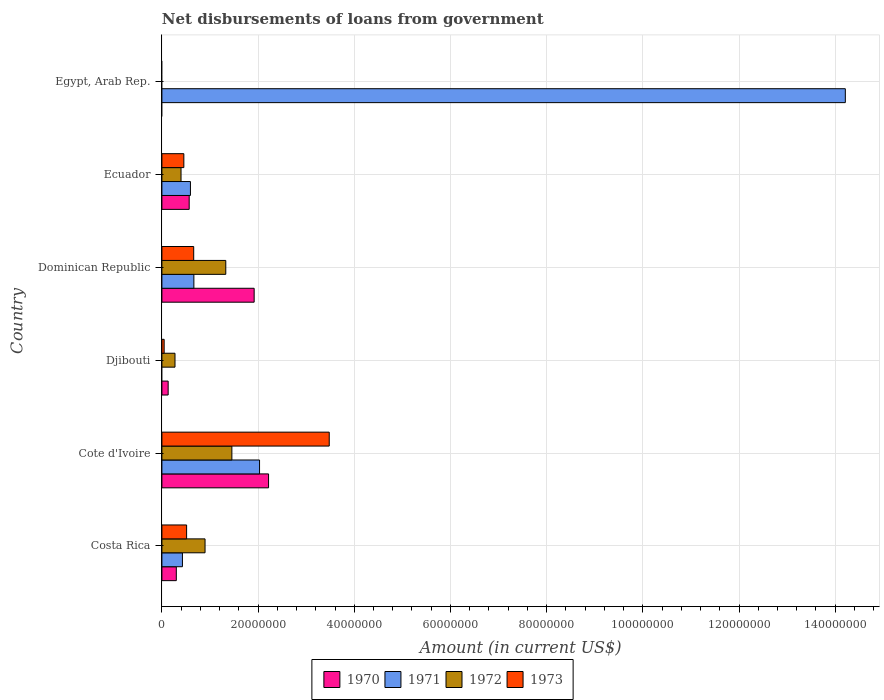Are the number of bars per tick equal to the number of legend labels?
Give a very brief answer. No. What is the label of the 6th group of bars from the top?
Ensure brevity in your answer.  Costa Rica. In how many cases, is the number of bars for a given country not equal to the number of legend labels?
Keep it short and to the point. 2. What is the amount of loan disbursed from government in 1971 in Egypt, Arab Rep.?
Offer a very short reply. 1.42e+08. Across all countries, what is the maximum amount of loan disbursed from government in 1973?
Your answer should be very brief. 3.48e+07. Across all countries, what is the minimum amount of loan disbursed from government in 1972?
Your answer should be compact. 0. In which country was the amount of loan disbursed from government in 1973 maximum?
Offer a very short reply. Cote d'Ivoire. What is the total amount of loan disbursed from government in 1970 in the graph?
Offer a terse response. 5.13e+07. What is the difference between the amount of loan disbursed from government in 1973 in Djibouti and that in Ecuador?
Keep it short and to the point. -4.10e+06. What is the difference between the amount of loan disbursed from government in 1973 in Egypt, Arab Rep. and the amount of loan disbursed from government in 1970 in Ecuador?
Provide a succinct answer. -5.67e+06. What is the average amount of loan disbursed from government in 1973 per country?
Provide a short and direct response. 8.60e+06. What is the difference between the amount of loan disbursed from government in 1972 and amount of loan disbursed from government in 1973 in Ecuador?
Your answer should be compact. -5.84e+05. What is the ratio of the amount of loan disbursed from government in 1973 in Dominican Republic to that in Ecuador?
Provide a short and direct response. 1.45. Is the amount of loan disbursed from government in 1972 in Cote d'Ivoire less than that in Dominican Republic?
Your answer should be very brief. No. What is the difference between the highest and the second highest amount of loan disbursed from government in 1973?
Provide a short and direct response. 2.82e+07. What is the difference between the highest and the lowest amount of loan disbursed from government in 1973?
Your answer should be compact. 3.48e+07. Is the sum of the amount of loan disbursed from government in 1972 in Djibouti and Dominican Republic greater than the maximum amount of loan disbursed from government in 1973 across all countries?
Provide a succinct answer. No. Is it the case that in every country, the sum of the amount of loan disbursed from government in 1972 and amount of loan disbursed from government in 1970 is greater than the amount of loan disbursed from government in 1971?
Give a very brief answer. No. What is the difference between two consecutive major ticks on the X-axis?
Ensure brevity in your answer.  2.00e+07. Are the values on the major ticks of X-axis written in scientific E-notation?
Your answer should be very brief. No. Does the graph contain any zero values?
Give a very brief answer. Yes. What is the title of the graph?
Your answer should be compact. Net disbursements of loans from government. Does "1982" appear as one of the legend labels in the graph?
Provide a succinct answer. No. What is the Amount (in current US$) in 1970 in Costa Rica?
Your answer should be very brief. 3.00e+06. What is the Amount (in current US$) of 1971 in Costa Rica?
Ensure brevity in your answer.  4.27e+06. What is the Amount (in current US$) in 1972 in Costa Rica?
Make the answer very short. 8.97e+06. What is the Amount (in current US$) of 1973 in Costa Rica?
Offer a very short reply. 5.14e+06. What is the Amount (in current US$) of 1970 in Cote d'Ivoire?
Keep it short and to the point. 2.22e+07. What is the Amount (in current US$) of 1971 in Cote d'Ivoire?
Your answer should be very brief. 2.03e+07. What is the Amount (in current US$) in 1972 in Cote d'Ivoire?
Ensure brevity in your answer.  1.45e+07. What is the Amount (in current US$) in 1973 in Cote d'Ivoire?
Your answer should be very brief. 3.48e+07. What is the Amount (in current US$) of 1970 in Djibouti?
Keep it short and to the point. 1.30e+06. What is the Amount (in current US$) in 1972 in Djibouti?
Offer a very short reply. 2.72e+06. What is the Amount (in current US$) of 1973 in Djibouti?
Your answer should be compact. 4.68e+05. What is the Amount (in current US$) of 1970 in Dominican Republic?
Provide a short and direct response. 1.92e+07. What is the Amount (in current US$) of 1971 in Dominican Republic?
Your answer should be very brief. 6.65e+06. What is the Amount (in current US$) of 1972 in Dominican Republic?
Provide a succinct answer. 1.33e+07. What is the Amount (in current US$) of 1973 in Dominican Republic?
Your response must be concise. 6.61e+06. What is the Amount (in current US$) of 1970 in Ecuador?
Give a very brief answer. 5.67e+06. What is the Amount (in current US$) in 1971 in Ecuador?
Provide a succinct answer. 5.93e+06. What is the Amount (in current US$) of 1972 in Ecuador?
Your answer should be compact. 3.98e+06. What is the Amount (in current US$) of 1973 in Ecuador?
Your answer should be very brief. 4.56e+06. What is the Amount (in current US$) of 1971 in Egypt, Arab Rep.?
Offer a terse response. 1.42e+08. What is the Amount (in current US$) in 1973 in Egypt, Arab Rep.?
Your answer should be very brief. 0. Across all countries, what is the maximum Amount (in current US$) in 1970?
Keep it short and to the point. 2.22e+07. Across all countries, what is the maximum Amount (in current US$) in 1971?
Offer a very short reply. 1.42e+08. Across all countries, what is the maximum Amount (in current US$) in 1972?
Your answer should be very brief. 1.45e+07. Across all countries, what is the maximum Amount (in current US$) in 1973?
Keep it short and to the point. 3.48e+07. Across all countries, what is the minimum Amount (in current US$) in 1971?
Make the answer very short. 0. What is the total Amount (in current US$) in 1970 in the graph?
Ensure brevity in your answer.  5.13e+07. What is the total Amount (in current US$) of 1971 in the graph?
Your answer should be very brief. 1.79e+08. What is the total Amount (in current US$) of 1972 in the graph?
Offer a very short reply. 4.35e+07. What is the total Amount (in current US$) in 1973 in the graph?
Your answer should be very brief. 5.16e+07. What is the difference between the Amount (in current US$) in 1970 in Costa Rica and that in Cote d'Ivoire?
Provide a succinct answer. -1.92e+07. What is the difference between the Amount (in current US$) of 1971 in Costa Rica and that in Cote d'Ivoire?
Keep it short and to the point. -1.60e+07. What is the difference between the Amount (in current US$) in 1972 in Costa Rica and that in Cote d'Ivoire?
Keep it short and to the point. -5.58e+06. What is the difference between the Amount (in current US$) of 1973 in Costa Rica and that in Cote d'Ivoire?
Make the answer very short. -2.97e+07. What is the difference between the Amount (in current US$) of 1970 in Costa Rica and that in Djibouti?
Your response must be concise. 1.70e+06. What is the difference between the Amount (in current US$) of 1972 in Costa Rica and that in Djibouti?
Give a very brief answer. 6.25e+06. What is the difference between the Amount (in current US$) in 1973 in Costa Rica and that in Djibouti?
Ensure brevity in your answer.  4.67e+06. What is the difference between the Amount (in current US$) of 1970 in Costa Rica and that in Dominican Republic?
Your response must be concise. -1.62e+07. What is the difference between the Amount (in current US$) of 1971 in Costa Rica and that in Dominican Republic?
Your answer should be very brief. -2.38e+06. What is the difference between the Amount (in current US$) in 1972 in Costa Rica and that in Dominican Republic?
Make the answer very short. -4.31e+06. What is the difference between the Amount (in current US$) of 1973 in Costa Rica and that in Dominican Republic?
Keep it short and to the point. -1.47e+06. What is the difference between the Amount (in current US$) of 1970 in Costa Rica and that in Ecuador?
Make the answer very short. -2.68e+06. What is the difference between the Amount (in current US$) of 1971 in Costa Rica and that in Ecuador?
Offer a terse response. -1.66e+06. What is the difference between the Amount (in current US$) in 1972 in Costa Rica and that in Ecuador?
Make the answer very short. 4.99e+06. What is the difference between the Amount (in current US$) of 1973 in Costa Rica and that in Ecuador?
Make the answer very short. 5.74e+05. What is the difference between the Amount (in current US$) of 1971 in Costa Rica and that in Egypt, Arab Rep.?
Make the answer very short. -1.38e+08. What is the difference between the Amount (in current US$) in 1970 in Cote d'Ivoire and that in Djibouti?
Give a very brief answer. 2.09e+07. What is the difference between the Amount (in current US$) of 1972 in Cote d'Ivoire and that in Djibouti?
Make the answer very short. 1.18e+07. What is the difference between the Amount (in current US$) of 1973 in Cote d'Ivoire and that in Djibouti?
Ensure brevity in your answer.  3.43e+07. What is the difference between the Amount (in current US$) in 1970 in Cote d'Ivoire and that in Dominican Republic?
Provide a short and direct response. 3.00e+06. What is the difference between the Amount (in current US$) in 1971 in Cote d'Ivoire and that in Dominican Republic?
Keep it short and to the point. 1.37e+07. What is the difference between the Amount (in current US$) in 1972 in Cote d'Ivoire and that in Dominican Republic?
Offer a terse response. 1.27e+06. What is the difference between the Amount (in current US$) in 1973 in Cote d'Ivoire and that in Dominican Republic?
Ensure brevity in your answer.  2.82e+07. What is the difference between the Amount (in current US$) in 1970 in Cote d'Ivoire and that in Ecuador?
Ensure brevity in your answer.  1.65e+07. What is the difference between the Amount (in current US$) of 1971 in Cote d'Ivoire and that in Ecuador?
Your answer should be compact. 1.44e+07. What is the difference between the Amount (in current US$) in 1972 in Cote d'Ivoire and that in Ecuador?
Provide a short and direct response. 1.06e+07. What is the difference between the Amount (in current US$) of 1973 in Cote d'Ivoire and that in Ecuador?
Provide a short and direct response. 3.02e+07. What is the difference between the Amount (in current US$) of 1971 in Cote d'Ivoire and that in Egypt, Arab Rep.?
Make the answer very short. -1.22e+08. What is the difference between the Amount (in current US$) of 1970 in Djibouti and that in Dominican Republic?
Your answer should be very brief. -1.79e+07. What is the difference between the Amount (in current US$) in 1972 in Djibouti and that in Dominican Republic?
Your answer should be very brief. -1.06e+07. What is the difference between the Amount (in current US$) in 1973 in Djibouti and that in Dominican Republic?
Your answer should be very brief. -6.14e+06. What is the difference between the Amount (in current US$) of 1970 in Djibouti and that in Ecuador?
Provide a succinct answer. -4.37e+06. What is the difference between the Amount (in current US$) in 1972 in Djibouti and that in Ecuador?
Your answer should be compact. -1.26e+06. What is the difference between the Amount (in current US$) in 1973 in Djibouti and that in Ecuador?
Keep it short and to the point. -4.10e+06. What is the difference between the Amount (in current US$) in 1970 in Dominican Republic and that in Ecuador?
Give a very brief answer. 1.35e+07. What is the difference between the Amount (in current US$) in 1971 in Dominican Republic and that in Ecuador?
Keep it short and to the point. 7.16e+05. What is the difference between the Amount (in current US$) of 1972 in Dominican Republic and that in Ecuador?
Your answer should be very brief. 9.30e+06. What is the difference between the Amount (in current US$) of 1973 in Dominican Republic and that in Ecuador?
Provide a succinct answer. 2.05e+06. What is the difference between the Amount (in current US$) of 1971 in Dominican Republic and that in Egypt, Arab Rep.?
Provide a short and direct response. -1.35e+08. What is the difference between the Amount (in current US$) of 1971 in Ecuador and that in Egypt, Arab Rep.?
Provide a succinct answer. -1.36e+08. What is the difference between the Amount (in current US$) of 1970 in Costa Rica and the Amount (in current US$) of 1971 in Cote d'Ivoire?
Make the answer very short. -1.73e+07. What is the difference between the Amount (in current US$) in 1970 in Costa Rica and the Amount (in current US$) in 1972 in Cote d'Ivoire?
Provide a succinct answer. -1.16e+07. What is the difference between the Amount (in current US$) in 1970 in Costa Rica and the Amount (in current US$) in 1973 in Cote d'Ivoire?
Your answer should be compact. -3.18e+07. What is the difference between the Amount (in current US$) in 1971 in Costa Rica and the Amount (in current US$) in 1972 in Cote d'Ivoire?
Provide a short and direct response. -1.03e+07. What is the difference between the Amount (in current US$) of 1971 in Costa Rica and the Amount (in current US$) of 1973 in Cote d'Ivoire?
Ensure brevity in your answer.  -3.05e+07. What is the difference between the Amount (in current US$) in 1972 in Costa Rica and the Amount (in current US$) in 1973 in Cote d'Ivoire?
Offer a terse response. -2.58e+07. What is the difference between the Amount (in current US$) in 1970 in Costa Rica and the Amount (in current US$) in 1972 in Djibouti?
Ensure brevity in your answer.  2.73e+05. What is the difference between the Amount (in current US$) of 1970 in Costa Rica and the Amount (in current US$) of 1973 in Djibouti?
Keep it short and to the point. 2.53e+06. What is the difference between the Amount (in current US$) of 1971 in Costa Rica and the Amount (in current US$) of 1972 in Djibouti?
Give a very brief answer. 1.55e+06. What is the difference between the Amount (in current US$) of 1971 in Costa Rica and the Amount (in current US$) of 1973 in Djibouti?
Provide a succinct answer. 3.80e+06. What is the difference between the Amount (in current US$) of 1972 in Costa Rica and the Amount (in current US$) of 1973 in Djibouti?
Offer a terse response. 8.50e+06. What is the difference between the Amount (in current US$) in 1970 in Costa Rica and the Amount (in current US$) in 1971 in Dominican Republic?
Provide a short and direct response. -3.65e+06. What is the difference between the Amount (in current US$) of 1970 in Costa Rica and the Amount (in current US$) of 1972 in Dominican Republic?
Your answer should be very brief. -1.03e+07. What is the difference between the Amount (in current US$) in 1970 in Costa Rica and the Amount (in current US$) in 1973 in Dominican Republic?
Your answer should be compact. -3.62e+06. What is the difference between the Amount (in current US$) of 1971 in Costa Rica and the Amount (in current US$) of 1972 in Dominican Republic?
Make the answer very short. -9.01e+06. What is the difference between the Amount (in current US$) of 1971 in Costa Rica and the Amount (in current US$) of 1973 in Dominican Republic?
Provide a succinct answer. -2.34e+06. What is the difference between the Amount (in current US$) of 1972 in Costa Rica and the Amount (in current US$) of 1973 in Dominican Republic?
Offer a very short reply. 2.36e+06. What is the difference between the Amount (in current US$) in 1970 in Costa Rica and the Amount (in current US$) in 1971 in Ecuador?
Your response must be concise. -2.94e+06. What is the difference between the Amount (in current US$) of 1970 in Costa Rica and the Amount (in current US$) of 1972 in Ecuador?
Your answer should be compact. -9.83e+05. What is the difference between the Amount (in current US$) in 1970 in Costa Rica and the Amount (in current US$) in 1973 in Ecuador?
Offer a terse response. -1.57e+06. What is the difference between the Amount (in current US$) of 1971 in Costa Rica and the Amount (in current US$) of 1973 in Ecuador?
Offer a very short reply. -2.94e+05. What is the difference between the Amount (in current US$) in 1972 in Costa Rica and the Amount (in current US$) in 1973 in Ecuador?
Your answer should be very brief. 4.41e+06. What is the difference between the Amount (in current US$) in 1970 in Costa Rica and the Amount (in current US$) in 1971 in Egypt, Arab Rep.?
Provide a short and direct response. -1.39e+08. What is the difference between the Amount (in current US$) of 1970 in Cote d'Ivoire and the Amount (in current US$) of 1972 in Djibouti?
Your answer should be compact. 1.95e+07. What is the difference between the Amount (in current US$) of 1970 in Cote d'Ivoire and the Amount (in current US$) of 1973 in Djibouti?
Provide a short and direct response. 2.17e+07. What is the difference between the Amount (in current US$) of 1971 in Cote d'Ivoire and the Amount (in current US$) of 1972 in Djibouti?
Offer a terse response. 1.76e+07. What is the difference between the Amount (in current US$) of 1971 in Cote d'Ivoire and the Amount (in current US$) of 1973 in Djibouti?
Make the answer very short. 1.98e+07. What is the difference between the Amount (in current US$) of 1972 in Cote d'Ivoire and the Amount (in current US$) of 1973 in Djibouti?
Offer a terse response. 1.41e+07. What is the difference between the Amount (in current US$) in 1970 in Cote d'Ivoire and the Amount (in current US$) in 1971 in Dominican Republic?
Give a very brief answer. 1.55e+07. What is the difference between the Amount (in current US$) in 1970 in Cote d'Ivoire and the Amount (in current US$) in 1972 in Dominican Republic?
Ensure brevity in your answer.  8.90e+06. What is the difference between the Amount (in current US$) in 1970 in Cote d'Ivoire and the Amount (in current US$) in 1973 in Dominican Republic?
Make the answer very short. 1.56e+07. What is the difference between the Amount (in current US$) of 1971 in Cote d'Ivoire and the Amount (in current US$) of 1972 in Dominican Republic?
Provide a succinct answer. 7.02e+06. What is the difference between the Amount (in current US$) of 1971 in Cote d'Ivoire and the Amount (in current US$) of 1973 in Dominican Republic?
Keep it short and to the point. 1.37e+07. What is the difference between the Amount (in current US$) of 1972 in Cote d'Ivoire and the Amount (in current US$) of 1973 in Dominican Republic?
Make the answer very short. 7.94e+06. What is the difference between the Amount (in current US$) of 1970 in Cote d'Ivoire and the Amount (in current US$) of 1971 in Ecuador?
Provide a short and direct response. 1.62e+07. What is the difference between the Amount (in current US$) of 1970 in Cote d'Ivoire and the Amount (in current US$) of 1972 in Ecuador?
Keep it short and to the point. 1.82e+07. What is the difference between the Amount (in current US$) in 1970 in Cote d'Ivoire and the Amount (in current US$) in 1973 in Ecuador?
Your response must be concise. 1.76e+07. What is the difference between the Amount (in current US$) in 1971 in Cote d'Ivoire and the Amount (in current US$) in 1972 in Ecuador?
Offer a very short reply. 1.63e+07. What is the difference between the Amount (in current US$) in 1971 in Cote d'Ivoire and the Amount (in current US$) in 1973 in Ecuador?
Keep it short and to the point. 1.57e+07. What is the difference between the Amount (in current US$) in 1972 in Cote d'Ivoire and the Amount (in current US$) in 1973 in Ecuador?
Give a very brief answer. 9.99e+06. What is the difference between the Amount (in current US$) of 1970 in Cote d'Ivoire and the Amount (in current US$) of 1971 in Egypt, Arab Rep.?
Give a very brief answer. -1.20e+08. What is the difference between the Amount (in current US$) in 1970 in Djibouti and the Amount (in current US$) in 1971 in Dominican Republic?
Provide a succinct answer. -5.35e+06. What is the difference between the Amount (in current US$) in 1970 in Djibouti and the Amount (in current US$) in 1972 in Dominican Republic?
Your answer should be compact. -1.20e+07. What is the difference between the Amount (in current US$) in 1970 in Djibouti and the Amount (in current US$) in 1973 in Dominican Republic?
Provide a succinct answer. -5.31e+06. What is the difference between the Amount (in current US$) in 1972 in Djibouti and the Amount (in current US$) in 1973 in Dominican Republic?
Your response must be concise. -3.89e+06. What is the difference between the Amount (in current US$) in 1970 in Djibouti and the Amount (in current US$) in 1971 in Ecuador?
Provide a succinct answer. -4.63e+06. What is the difference between the Amount (in current US$) of 1970 in Djibouti and the Amount (in current US$) of 1972 in Ecuador?
Make the answer very short. -2.68e+06. What is the difference between the Amount (in current US$) of 1970 in Djibouti and the Amount (in current US$) of 1973 in Ecuador?
Offer a very short reply. -3.26e+06. What is the difference between the Amount (in current US$) in 1972 in Djibouti and the Amount (in current US$) in 1973 in Ecuador?
Offer a terse response. -1.84e+06. What is the difference between the Amount (in current US$) in 1970 in Djibouti and the Amount (in current US$) in 1971 in Egypt, Arab Rep.?
Your response must be concise. -1.41e+08. What is the difference between the Amount (in current US$) of 1970 in Dominican Republic and the Amount (in current US$) of 1971 in Ecuador?
Offer a very short reply. 1.32e+07. What is the difference between the Amount (in current US$) of 1970 in Dominican Republic and the Amount (in current US$) of 1972 in Ecuador?
Give a very brief answer. 1.52e+07. What is the difference between the Amount (in current US$) of 1970 in Dominican Republic and the Amount (in current US$) of 1973 in Ecuador?
Your answer should be very brief. 1.46e+07. What is the difference between the Amount (in current US$) of 1971 in Dominican Republic and the Amount (in current US$) of 1972 in Ecuador?
Make the answer very short. 2.67e+06. What is the difference between the Amount (in current US$) of 1971 in Dominican Republic and the Amount (in current US$) of 1973 in Ecuador?
Your answer should be very brief. 2.09e+06. What is the difference between the Amount (in current US$) in 1972 in Dominican Republic and the Amount (in current US$) in 1973 in Ecuador?
Your answer should be very brief. 8.72e+06. What is the difference between the Amount (in current US$) in 1970 in Dominican Republic and the Amount (in current US$) in 1971 in Egypt, Arab Rep.?
Your response must be concise. -1.23e+08. What is the difference between the Amount (in current US$) of 1970 in Ecuador and the Amount (in current US$) of 1971 in Egypt, Arab Rep.?
Ensure brevity in your answer.  -1.36e+08. What is the average Amount (in current US$) of 1970 per country?
Give a very brief answer. 8.56e+06. What is the average Amount (in current US$) in 1971 per country?
Offer a terse response. 2.99e+07. What is the average Amount (in current US$) of 1972 per country?
Provide a succinct answer. 7.25e+06. What is the average Amount (in current US$) in 1973 per country?
Offer a very short reply. 8.60e+06. What is the difference between the Amount (in current US$) of 1970 and Amount (in current US$) of 1971 in Costa Rica?
Give a very brief answer. -1.27e+06. What is the difference between the Amount (in current US$) in 1970 and Amount (in current US$) in 1972 in Costa Rica?
Your response must be concise. -5.98e+06. What is the difference between the Amount (in current US$) in 1970 and Amount (in current US$) in 1973 in Costa Rica?
Offer a very short reply. -2.14e+06. What is the difference between the Amount (in current US$) in 1971 and Amount (in current US$) in 1972 in Costa Rica?
Offer a terse response. -4.70e+06. What is the difference between the Amount (in current US$) in 1971 and Amount (in current US$) in 1973 in Costa Rica?
Provide a short and direct response. -8.68e+05. What is the difference between the Amount (in current US$) in 1972 and Amount (in current US$) in 1973 in Costa Rica?
Your answer should be very brief. 3.84e+06. What is the difference between the Amount (in current US$) of 1970 and Amount (in current US$) of 1971 in Cote d'Ivoire?
Offer a very short reply. 1.88e+06. What is the difference between the Amount (in current US$) of 1970 and Amount (in current US$) of 1972 in Cote d'Ivoire?
Your answer should be very brief. 7.63e+06. What is the difference between the Amount (in current US$) in 1970 and Amount (in current US$) in 1973 in Cote d'Ivoire?
Give a very brief answer. -1.26e+07. What is the difference between the Amount (in current US$) of 1971 and Amount (in current US$) of 1972 in Cote d'Ivoire?
Give a very brief answer. 5.75e+06. What is the difference between the Amount (in current US$) of 1971 and Amount (in current US$) of 1973 in Cote d'Ivoire?
Give a very brief answer. -1.45e+07. What is the difference between the Amount (in current US$) of 1972 and Amount (in current US$) of 1973 in Cote d'Ivoire?
Keep it short and to the point. -2.02e+07. What is the difference between the Amount (in current US$) in 1970 and Amount (in current US$) in 1972 in Djibouti?
Make the answer very short. -1.42e+06. What is the difference between the Amount (in current US$) in 1970 and Amount (in current US$) in 1973 in Djibouti?
Provide a succinct answer. 8.32e+05. What is the difference between the Amount (in current US$) of 1972 and Amount (in current US$) of 1973 in Djibouti?
Your answer should be very brief. 2.26e+06. What is the difference between the Amount (in current US$) of 1970 and Amount (in current US$) of 1971 in Dominican Republic?
Provide a succinct answer. 1.25e+07. What is the difference between the Amount (in current US$) of 1970 and Amount (in current US$) of 1972 in Dominican Republic?
Make the answer very short. 5.90e+06. What is the difference between the Amount (in current US$) of 1970 and Amount (in current US$) of 1973 in Dominican Republic?
Your answer should be very brief. 1.26e+07. What is the difference between the Amount (in current US$) in 1971 and Amount (in current US$) in 1972 in Dominican Republic?
Offer a terse response. -6.63e+06. What is the difference between the Amount (in current US$) in 1971 and Amount (in current US$) in 1973 in Dominican Republic?
Make the answer very short. 3.80e+04. What is the difference between the Amount (in current US$) of 1972 and Amount (in current US$) of 1973 in Dominican Republic?
Keep it short and to the point. 6.67e+06. What is the difference between the Amount (in current US$) of 1970 and Amount (in current US$) of 1972 in Ecuador?
Give a very brief answer. 1.69e+06. What is the difference between the Amount (in current US$) of 1970 and Amount (in current US$) of 1973 in Ecuador?
Your answer should be very brief. 1.11e+06. What is the difference between the Amount (in current US$) in 1971 and Amount (in current US$) in 1972 in Ecuador?
Your response must be concise. 1.95e+06. What is the difference between the Amount (in current US$) of 1971 and Amount (in current US$) of 1973 in Ecuador?
Ensure brevity in your answer.  1.37e+06. What is the difference between the Amount (in current US$) of 1972 and Amount (in current US$) of 1973 in Ecuador?
Give a very brief answer. -5.84e+05. What is the ratio of the Amount (in current US$) in 1970 in Costa Rica to that in Cote d'Ivoire?
Offer a terse response. 0.14. What is the ratio of the Amount (in current US$) in 1971 in Costa Rica to that in Cote d'Ivoire?
Offer a terse response. 0.21. What is the ratio of the Amount (in current US$) of 1972 in Costa Rica to that in Cote d'Ivoire?
Your response must be concise. 0.62. What is the ratio of the Amount (in current US$) of 1973 in Costa Rica to that in Cote d'Ivoire?
Keep it short and to the point. 0.15. What is the ratio of the Amount (in current US$) in 1970 in Costa Rica to that in Djibouti?
Ensure brevity in your answer.  2.3. What is the ratio of the Amount (in current US$) of 1972 in Costa Rica to that in Djibouti?
Your answer should be very brief. 3.29. What is the ratio of the Amount (in current US$) of 1973 in Costa Rica to that in Djibouti?
Give a very brief answer. 10.98. What is the ratio of the Amount (in current US$) in 1970 in Costa Rica to that in Dominican Republic?
Offer a very short reply. 0.16. What is the ratio of the Amount (in current US$) in 1971 in Costa Rica to that in Dominican Republic?
Ensure brevity in your answer.  0.64. What is the ratio of the Amount (in current US$) in 1972 in Costa Rica to that in Dominican Republic?
Make the answer very short. 0.68. What is the ratio of the Amount (in current US$) in 1973 in Costa Rica to that in Dominican Republic?
Provide a succinct answer. 0.78. What is the ratio of the Amount (in current US$) in 1970 in Costa Rica to that in Ecuador?
Give a very brief answer. 0.53. What is the ratio of the Amount (in current US$) of 1971 in Costa Rica to that in Ecuador?
Your answer should be compact. 0.72. What is the ratio of the Amount (in current US$) of 1972 in Costa Rica to that in Ecuador?
Provide a succinct answer. 2.25. What is the ratio of the Amount (in current US$) in 1973 in Costa Rica to that in Ecuador?
Make the answer very short. 1.13. What is the ratio of the Amount (in current US$) in 1971 in Costa Rica to that in Egypt, Arab Rep.?
Offer a very short reply. 0.03. What is the ratio of the Amount (in current US$) of 1970 in Cote d'Ivoire to that in Djibouti?
Your answer should be compact. 17.06. What is the ratio of the Amount (in current US$) of 1972 in Cote d'Ivoire to that in Djibouti?
Your answer should be very brief. 5.34. What is the ratio of the Amount (in current US$) of 1973 in Cote d'Ivoire to that in Djibouti?
Make the answer very short. 74.34. What is the ratio of the Amount (in current US$) of 1970 in Cote d'Ivoire to that in Dominican Republic?
Your response must be concise. 1.16. What is the ratio of the Amount (in current US$) of 1971 in Cote d'Ivoire to that in Dominican Republic?
Keep it short and to the point. 3.05. What is the ratio of the Amount (in current US$) in 1972 in Cote d'Ivoire to that in Dominican Republic?
Ensure brevity in your answer.  1.1. What is the ratio of the Amount (in current US$) in 1973 in Cote d'Ivoire to that in Dominican Republic?
Offer a very short reply. 5.26. What is the ratio of the Amount (in current US$) of 1970 in Cote d'Ivoire to that in Ecuador?
Give a very brief answer. 3.91. What is the ratio of the Amount (in current US$) in 1971 in Cote d'Ivoire to that in Ecuador?
Your answer should be compact. 3.42. What is the ratio of the Amount (in current US$) of 1972 in Cote d'Ivoire to that in Ecuador?
Your answer should be very brief. 3.66. What is the ratio of the Amount (in current US$) in 1973 in Cote d'Ivoire to that in Ecuador?
Make the answer very short. 7.62. What is the ratio of the Amount (in current US$) of 1971 in Cote d'Ivoire to that in Egypt, Arab Rep.?
Your response must be concise. 0.14. What is the ratio of the Amount (in current US$) in 1970 in Djibouti to that in Dominican Republic?
Give a very brief answer. 0.07. What is the ratio of the Amount (in current US$) in 1972 in Djibouti to that in Dominican Republic?
Offer a terse response. 0.2. What is the ratio of the Amount (in current US$) of 1973 in Djibouti to that in Dominican Republic?
Make the answer very short. 0.07. What is the ratio of the Amount (in current US$) of 1970 in Djibouti to that in Ecuador?
Make the answer very short. 0.23. What is the ratio of the Amount (in current US$) of 1972 in Djibouti to that in Ecuador?
Make the answer very short. 0.68. What is the ratio of the Amount (in current US$) of 1973 in Djibouti to that in Ecuador?
Your response must be concise. 0.1. What is the ratio of the Amount (in current US$) in 1970 in Dominican Republic to that in Ecuador?
Your answer should be compact. 3.38. What is the ratio of the Amount (in current US$) in 1971 in Dominican Republic to that in Ecuador?
Offer a terse response. 1.12. What is the ratio of the Amount (in current US$) of 1972 in Dominican Republic to that in Ecuador?
Keep it short and to the point. 3.34. What is the ratio of the Amount (in current US$) in 1973 in Dominican Republic to that in Ecuador?
Offer a very short reply. 1.45. What is the ratio of the Amount (in current US$) of 1971 in Dominican Republic to that in Egypt, Arab Rep.?
Make the answer very short. 0.05. What is the ratio of the Amount (in current US$) in 1971 in Ecuador to that in Egypt, Arab Rep.?
Your answer should be compact. 0.04. What is the difference between the highest and the second highest Amount (in current US$) of 1970?
Your answer should be compact. 3.00e+06. What is the difference between the highest and the second highest Amount (in current US$) of 1971?
Your response must be concise. 1.22e+08. What is the difference between the highest and the second highest Amount (in current US$) of 1972?
Provide a short and direct response. 1.27e+06. What is the difference between the highest and the second highest Amount (in current US$) of 1973?
Keep it short and to the point. 2.82e+07. What is the difference between the highest and the lowest Amount (in current US$) in 1970?
Make the answer very short. 2.22e+07. What is the difference between the highest and the lowest Amount (in current US$) of 1971?
Your answer should be compact. 1.42e+08. What is the difference between the highest and the lowest Amount (in current US$) in 1972?
Ensure brevity in your answer.  1.45e+07. What is the difference between the highest and the lowest Amount (in current US$) of 1973?
Your answer should be very brief. 3.48e+07. 